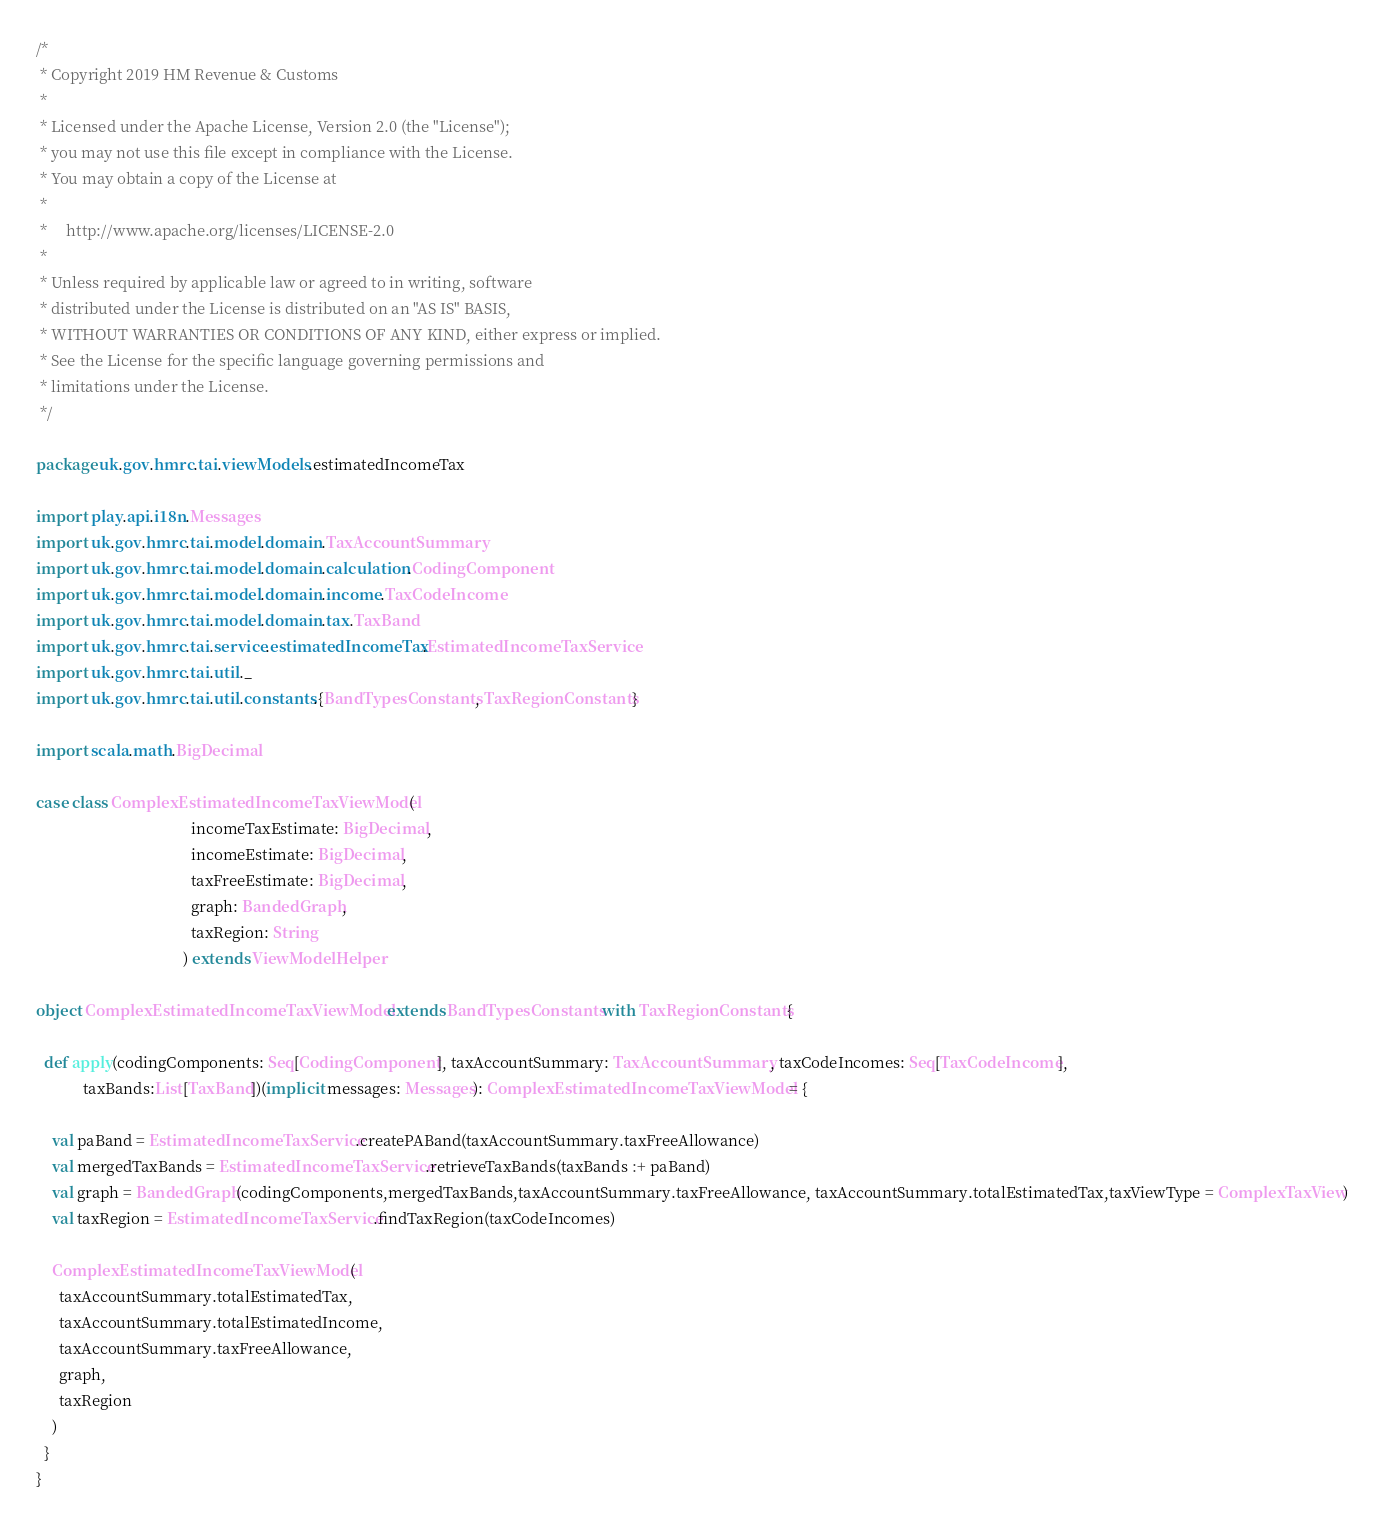<code> <loc_0><loc_0><loc_500><loc_500><_Scala_>/*
 * Copyright 2019 HM Revenue & Customs
 *
 * Licensed under the Apache License, Version 2.0 (the "License");
 * you may not use this file except in compliance with the License.
 * You may obtain a copy of the License at
 *
 *     http://www.apache.org/licenses/LICENSE-2.0
 *
 * Unless required by applicable law or agreed to in writing, software
 * distributed under the License is distributed on an "AS IS" BASIS,
 * WITHOUT WARRANTIES OR CONDITIONS OF ANY KIND, either express or implied.
 * See the License for the specific language governing permissions and
 * limitations under the License.
 */

package uk.gov.hmrc.tai.viewModels.estimatedIncomeTax

import play.api.i18n.Messages
import uk.gov.hmrc.tai.model.domain.TaxAccountSummary
import uk.gov.hmrc.tai.model.domain.calculation.CodingComponent
import uk.gov.hmrc.tai.model.domain.income.TaxCodeIncome
import uk.gov.hmrc.tai.model.domain.tax.TaxBand
import uk.gov.hmrc.tai.service.estimatedIncomeTax.EstimatedIncomeTaxService
import uk.gov.hmrc.tai.util._
import uk.gov.hmrc.tai.util.constants.{BandTypesConstants, TaxRegionConstants}

import scala.math.BigDecimal

case class ComplexEstimatedIncomeTaxViewModel(
                                        incomeTaxEstimate: BigDecimal,
                                        incomeEstimate: BigDecimal,
                                        taxFreeEstimate: BigDecimal,
                                        graph: BandedGraph,
                                        taxRegion: String
                                      ) extends ViewModelHelper

object ComplexEstimatedIncomeTaxViewModel extends BandTypesConstants with TaxRegionConstants{

  def apply(codingComponents: Seq[CodingComponent], taxAccountSummary: TaxAccountSummary, taxCodeIncomes: Seq[TaxCodeIncome],
            taxBands:List[TaxBand])(implicit messages: Messages): ComplexEstimatedIncomeTaxViewModel = {

    val paBand = EstimatedIncomeTaxService.createPABand(taxAccountSummary.taxFreeAllowance)
    val mergedTaxBands = EstimatedIncomeTaxService.retrieveTaxBands(taxBands :+ paBand)
    val graph = BandedGraph(codingComponents,mergedTaxBands,taxAccountSummary.taxFreeAllowance, taxAccountSummary.totalEstimatedTax,taxViewType = ComplexTaxView)
    val taxRegion = EstimatedIncomeTaxService.findTaxRegion(taxCodeIncomes)

    ComplexEstimatedIncomeTaxViewModel(
      taxAccountSummary.totalEstimatedTax,
      taxAccountSummary.totalEstimatedIncome,
      taxAccountSummary.taxFreeAllowance,
      graph,
      taxRegion
    )
  }
}
</code> 